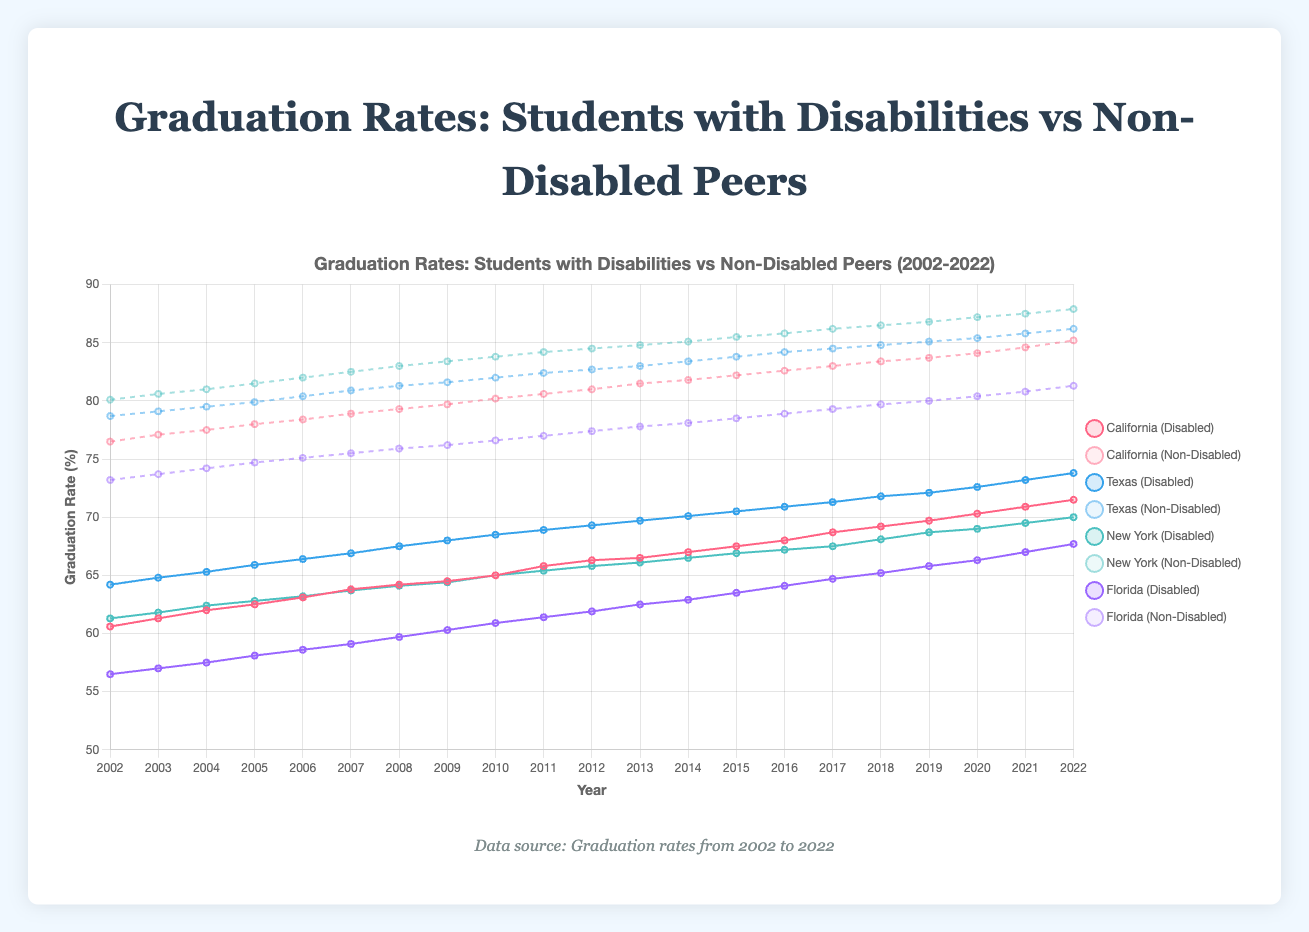Which state had the highest graduation rate for students with disabilities in 2022? To determine which state had the highest graduation rate for students with disabilities in 2022, look at the end data points for each state in the graph. According to the data, Texas had the highest graduation rate for students with disabilities in 2022 with a rate of 73.8%.
Answer: Texas How did the graduation rate for non-disabled students in California change from 2010 to 2020? To find how the graduation rate for non-disabled students in California changed from 2010 to 2020, locate the data points for these years on the line and calculate the difference. In 2010, the rate was 80.2%, and by 2020, it had increased to 84.1%. Subtract the 2010 rate from the 2020 rate: 84.1% - 80.2% = 3.9%.
Answer: Increased by 3.9% For which year was the difference between the graduation rates of non-disabled students and students with disabilities the smallest in New York? To find the year with the smallest difference in New York, calculate the difference between the graduation rates of non-disabled students and students with disabilities for each year and compare them. The smallest difference occurred in 2022: for non-disabled students, the rate was 87.9%, and for students with disabilities, it was 70%, resulting in a difference of 87.9% - 70% = 17.9%.
Answer: 2022 Compare the trend in graduation rates of students with disabilities from 2002 to 2022 in California and Florida. To compare the trends, observe the overall upward slope of the lines representing California and Florida from 2002 to 2022. Both states show a similar upward trend, indicating an increase in graduation rates over time. Specifically, California's rate increased from 60.6% to 71.5%, while Florida's rate increased from 56.5% to 67.7%.
Answer: Both upward What is the average graduation rate for non-disabled students in Texas from 2002 to 2022? To find the average graduation rate for non-disabled students in Texas from 2002 to 2022, sum the graduation rates for each year and divide by the number of years (21). Sum of rates: 78.7 + 79.1 + 79.5 + 79.9 + 80.4 + 80.9 + 81.3 + 81.6 + 82.0 + 82.4 + 82.7 + 83.0 + 83.4 + 83.8 + 84.2 + 84.5 + 84.8 + 85.1 + 85.4 + 85.8 + 86.2 = 1702.7. Then, 1702.7 / 21 = 81.08%.
Answer: 81.08% Visually, which state had the most significant visual gap between the graduation rates of students with disabilities and non-disabled students in 2005? To find the state with the most significant visual gap between the graduation rates of students with disabilities and non-disabled students in 2005, compare the distances between the paired lines for each state in 2005. The most significant gap is observed in New York: for non-disabled students, the rate was 81.5%, and for students with disabilities, it was 62.8%, resulting in a visual gap of approximately 18.7 percentage points.
Answer: New York 